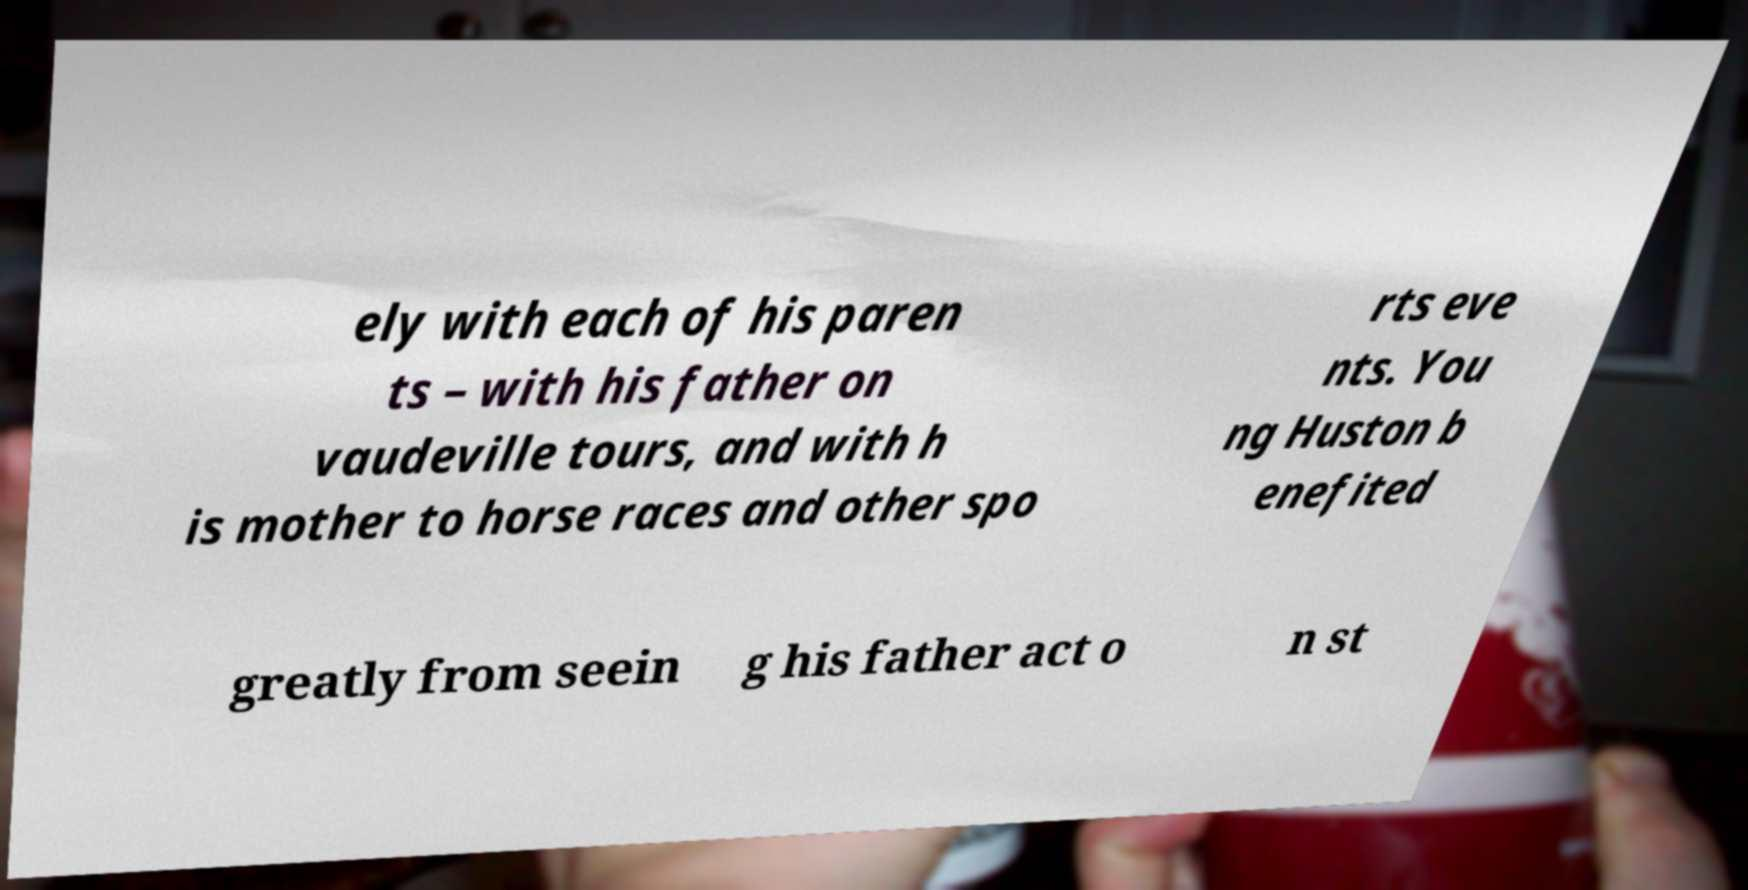Please read and relay the text visible in this image. What does it say? ely with each of his paren ts – with his father on vaudeville tours, and with h is mother to horse races and other spo rts eve nts. You ng Huston b enefited greatly from seein g his father act o n st 